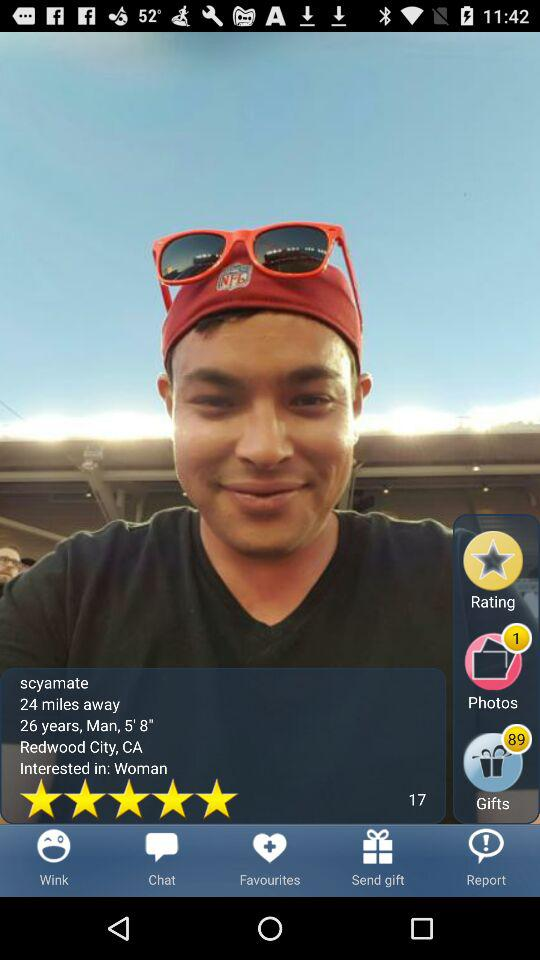What is the age? The age is 26 years. 